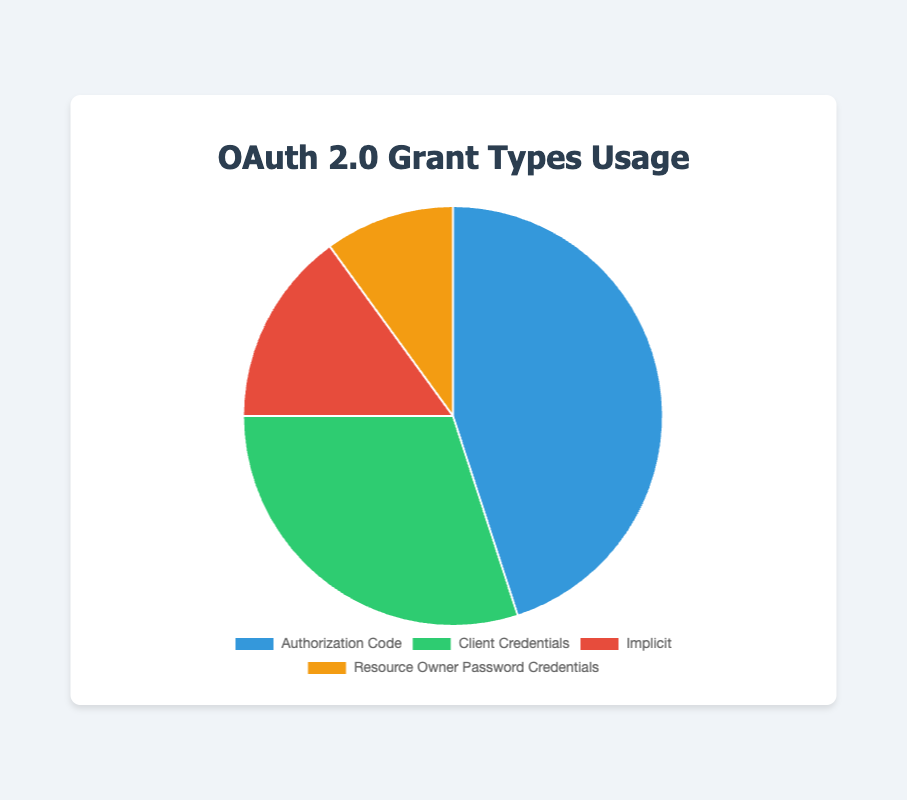What percentage of API clients are using the "Authorization Code" grant type? "Authorization Code" has a slice labeled 45% on the pie chart. Therefore, 45% of API clients use this grant type.
Answer: 45% What is the difference in percentage between "Client Credentials" and "Implicit" grant types? "Client Credentials" is at 30%, and "Implicit" is at 15%. The difference is calculated as 30% - 15% = 15%.
Answer: 15% Which grant type is utilized by the least percentage of API clients? Among the slices on the pie chart, "Resource Owner Password Credentials" has the smallest percentage at 10%.
Answer: Resource Owner Password Credentials What is the total percentage of clients using either "Authorization Code" or "Client Credentials" grant types? Adding the percentages for "Authorization Code" (45%) and "Client Credentials" (30%) gives 45% + 30% = 75%.
Answer: 75% Which grant type is represented by the green slice in the pie chart? The green slice corresponds to the "Client Credentials" grant type as it's associated with 30% usage.
Answer: Client Credentials What is the ratio of clients using the "Authorization Code" grant type to those using the "Implicit" grant type? The "Authorization Code" is used by 45% of clients and the "Implicit" by 15%. Therefore, the ratio is 45 / 15 = 3:1.
Answer: 3:1 What percentage more clients utilize the "Authorization Code" grant type compared to "Resource Owner Password Credentials"? "Authorization Code" is at 45%, and "Resource Owner Password Credentials" is at 10%. The percentage more is 45% - 10% = 35%.
Answer: 35% If the total number of API clients is 200, how many clients use the "Client Credentials" grant type? With 30% of clients using "Client Credentials" and a total of 200 clients, the calculation is 0.30 * 200 = 60 clients.
Answer: 60 Which grant type has a 15% representation in the pie chart? The slice showing 15% corresponds to the "Implicit" grant type.
Answer: Implicit How many more clients utilize the "Authorization Code" grant type compared to the "Implicit" grant type if there are 100 total clients? With 45% using "Authorization Code" and 15% using "Implicit", for 100 clients this means 45 - 15 = 30 clients more.
Answer: 30 